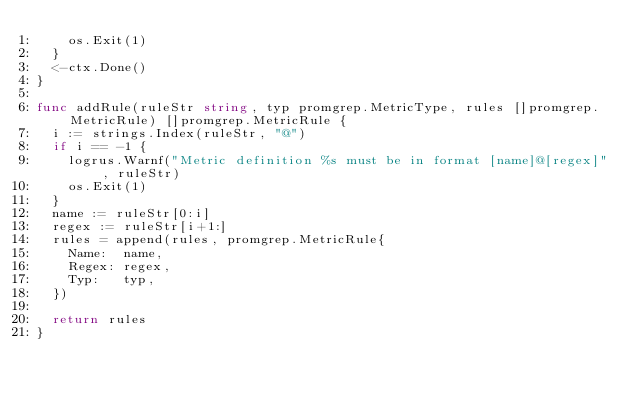<code> <loc_0><loc_0><loc_500><loc_500><_Go_>		os.Exit(1)
	}
	<-ctx.Done()
}

func addRule(ruleStr string, typ promgrep.MetricType, rules []promgrep.MetricRule) []promgrep.MetricRule {
	i := strings.Index(ruleStr, "@")
	if i == -1 {
		logrus.Warnf("Metric definition %s must be in format [name]@[regex]", ruleStr)
		os.Exit(1)
	}
	name := ruleStr[0:i]
	regex := ruleStr[i+1:]
	rules = append(rules, promgrep.MetricRule{
		Name:  name,
		Regex: regex,
		Typ:   typ,
	})

	return rules
}
</code> 